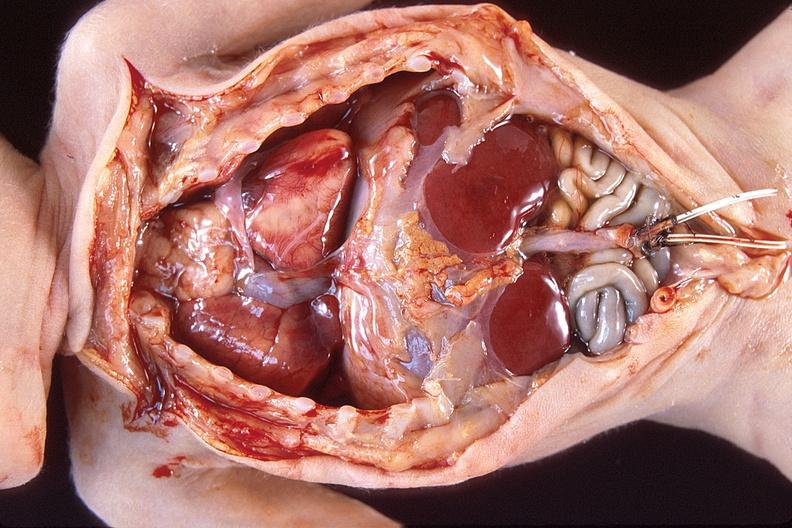does subdiaphragmatic abscess show hyaline membrane disease?
Answer the question using a single word or phrase. No 